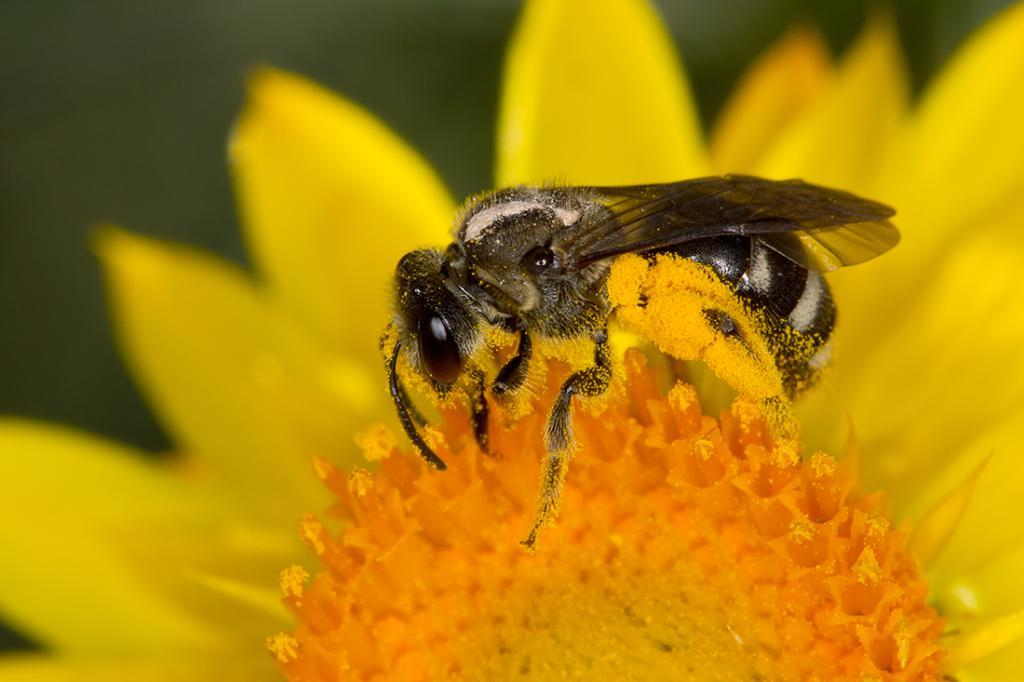What type of flower is present in the image? There is a yellow flower in the image. Are there any other living organisms visible in the image? Yes, there is an insect in the image. What type of jewel is the doll holding in the image? There is no doll or jewel present in the image; it only features a yellow flower and an insect. 